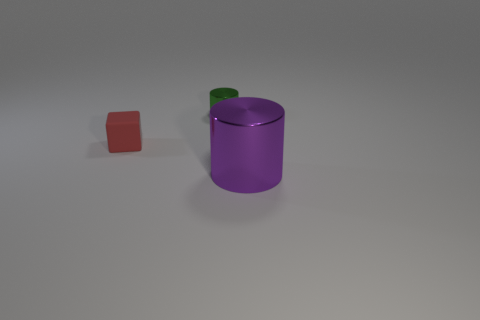Add 3 large blue metallic spheres. How many objects exist? 6 Subtract all blocks. How many objects are left? 2 Subtract 0 cyan blocks. How many objects are left? 3 Subtract all shiny things. Subtract all big objects. How many objects are left? 0 Add 1 tiny matte cubes. How many tiny matte cubes are left? 2 Add 1 cylinders. How many cylinders exist? 3 